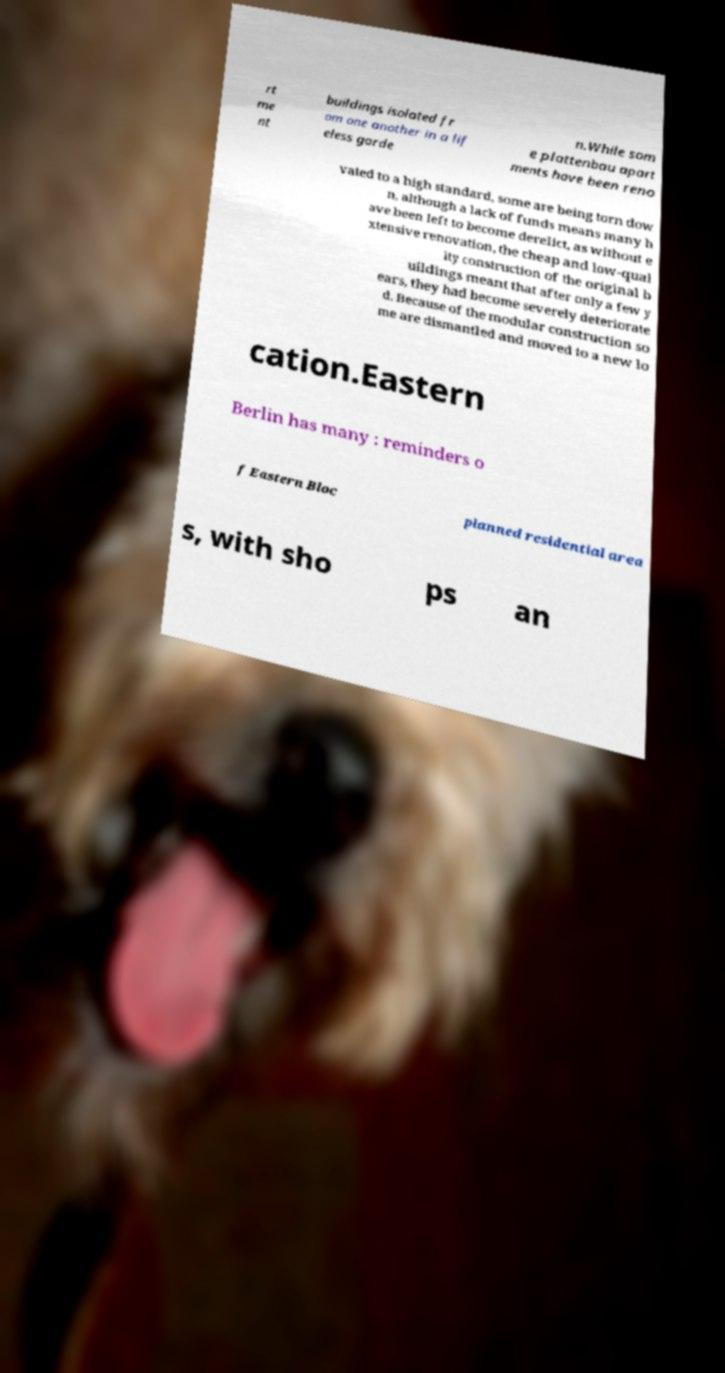Could you assist in decoding the text presented in this image and type it out clearly? rt me nt buildings isolated fr om one another in a lif eless garde n.While som e plattenbau apart ments have been reno vated to a high standard, some are being torn dow n, although a lack of funds means many h ave been left to become derelict, as without e xtensive renovation, the cheap and low-qual ity construction of the original b uildings meant that after only a few y ears, they had become severely deteriorate d. Because of the modular construction so me are dismantled and moved to a new lo cation.Eastern Berlin has many : reminders o f Eastern Bloc planned residential area s, with sho ps an 